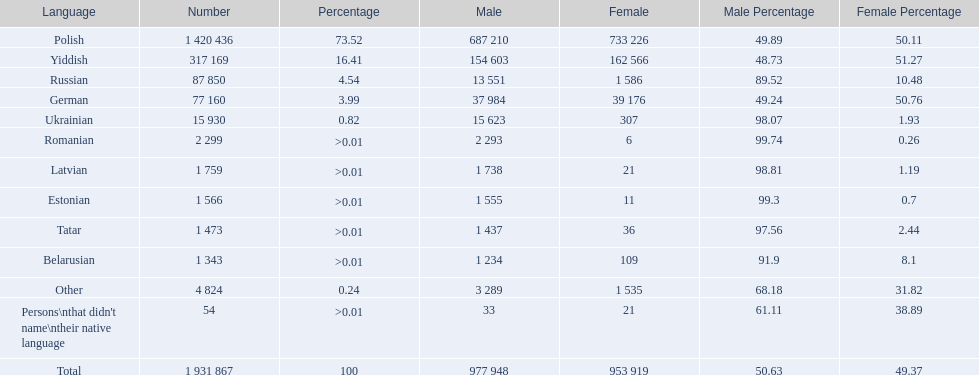What are all the languages? Polish, Yiddish, Russian, German, Ukrainian, Romanian, Latvian, Estonian, Tatar, Belarusian, Other, Persons\nthat didn't name\ntheir native language. Of those languages, which five had fewer than 50 females speaking it? 6, 21, 11, 36, 21. Of those five languages, which is the lowest? Romanian. 